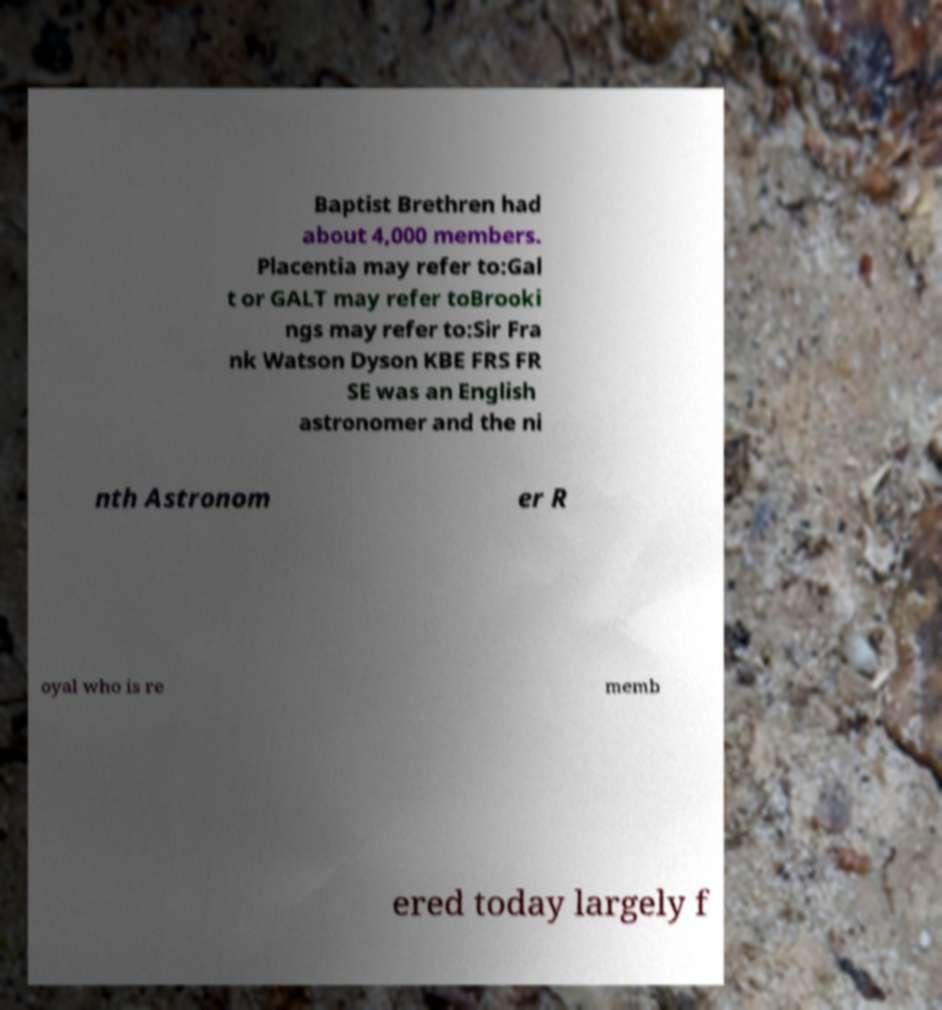Could you extract and type out the text from this image? Baptist Brethren had about 4,000 members. Placentia may refer to:Gal t or GALT may refer toBrooki ngs may refer to:Sir Fra nk Watson Dyson KBE FRS FR SE was an English astronomer and the ni nth Astronom er R oyal who is re memb ered today largely f 